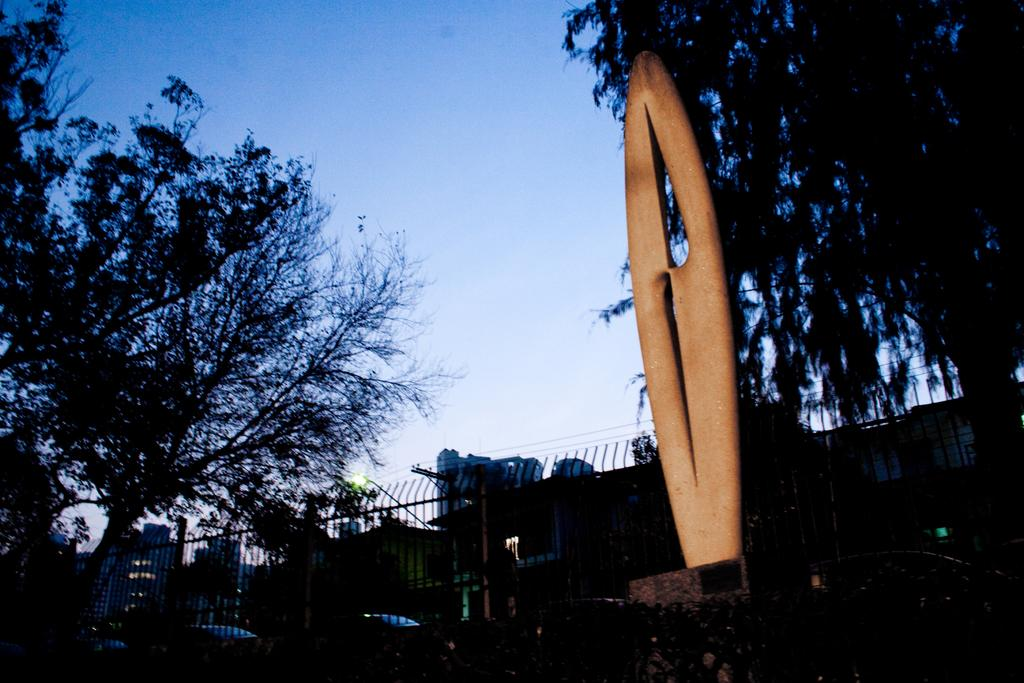What is the main subject of the image? There is a statue in the image. What other objects can be seen in the image? There are grills and trees visible in the image. What can be seen in the background of the image? There are buildings and vehicles visible in the background of the image. What part of the natural environment is visible in the image? The sky is visible in the image. How many clouds can be seen in the image? There are no clouds visible in the image; only the sky is visible. What type of bulb is used to light up the statue in the image? There is no bulb present in the image, as the statue is outdoors and not illuminated by a bulb. 